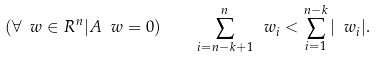Convert formula to latex. <formula><loc_0><loc_0><loc_500><loc_500>( \forall \ w \in R ^ { n } | A \ w = 0 ) \quad \sum _ { i = n - k + 1 } ^ { n } \ w _ { i } < \sum _ { i = 1 } ^ { n - k } | \ w _ { i } | .</formula> 